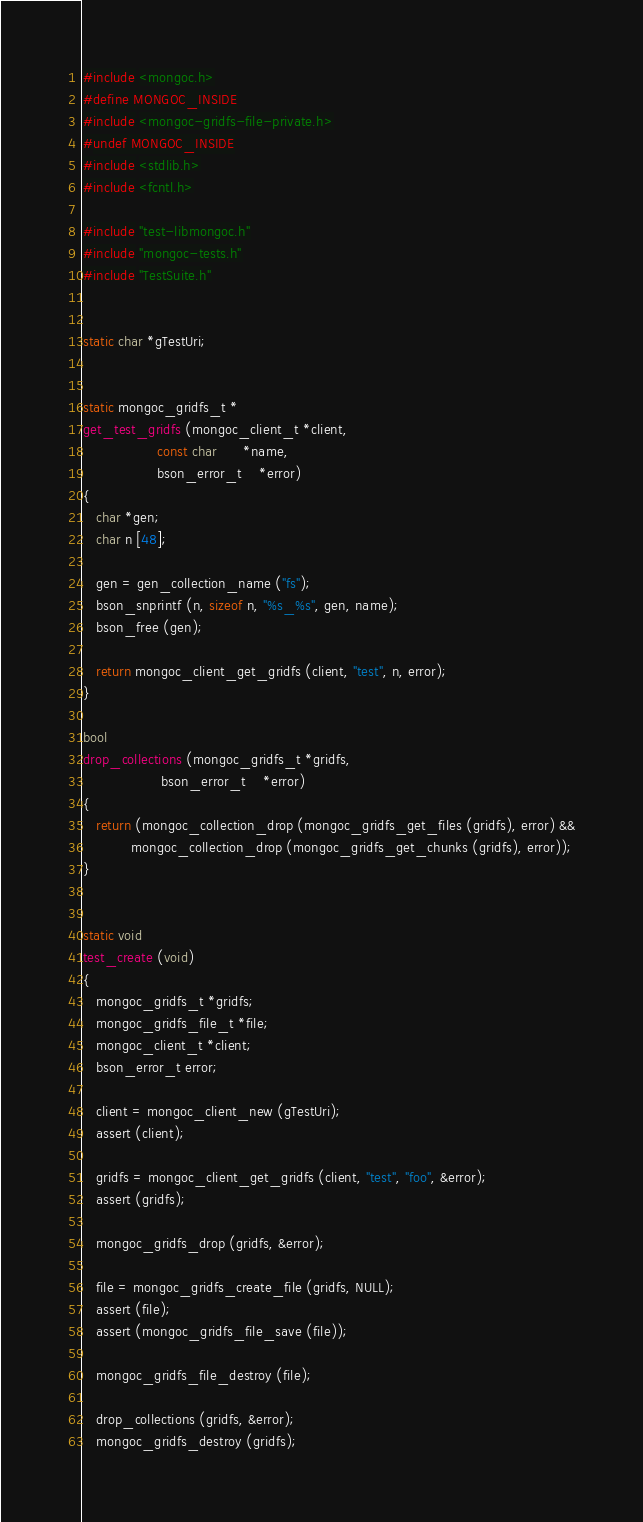<code> <loc_0><loc_0><loc_500><loc_500><_C_>#include <mongoc.h>
#define MONGOC_INSIDE
#include <mongoc-gridfs-file-private.h>
#undef MONGOC_INSIDE
#include <stdlib.h>
#include <fcntl.h>

#include "test-libmongoc.h"
#include "mongoc-tests.h"
#include "TestSuite.h"


static char *gTestUri;


static mongoc_gridfs_t *
get_test_gridfs (mongoc_client_t *client,
                 const char      *name,
                 bson_error_t    *error)
{
   char *gen;
   char n [48];

   gen = gen_collection_name ("fs");
   bson_snprintf (n, sizeof n, "%s_%s", gen, name);
   bson_free (gen);

   return mongoc_client_get_gridfs (client, "test", n, error);
}

bool
drop_collections (mongoc_gridfs_t *gridfs,
                  bson_error_t    *error)
{
   return (mongoc_collection_drop (mongoc_gridfs_get_files (gridfs), error) &&
           mongoc_collection_drop (mongoc_gridfs_get_chunks (gridfs), error));
}


static void
test_create (void)
{
   mongoc_gridfs_t *gridfs;
   mongoc_gridfs_file_t *file;
   mongoc_client_t *client;
   bson_error_t error;

   client = mongoc_client_new (gTestUri);
   assert (client);

   gridfs = mongoc_client_get_gridfs (client, "test", "foo", &error);
   assert (gridfs);

   mongoc_gridfs_drop (gridfs, &error);

   file = mongoc_gridfs_create_file (gridfs, NULL);
   assert (file);
   assert (mongoc_gridfs_file_save (file));

   mongoc_gridfs_file_destroy (file);

   drop_collections (gridfs, &error);
   mongoc_gridfs_destroy (gridfs);
</code> 